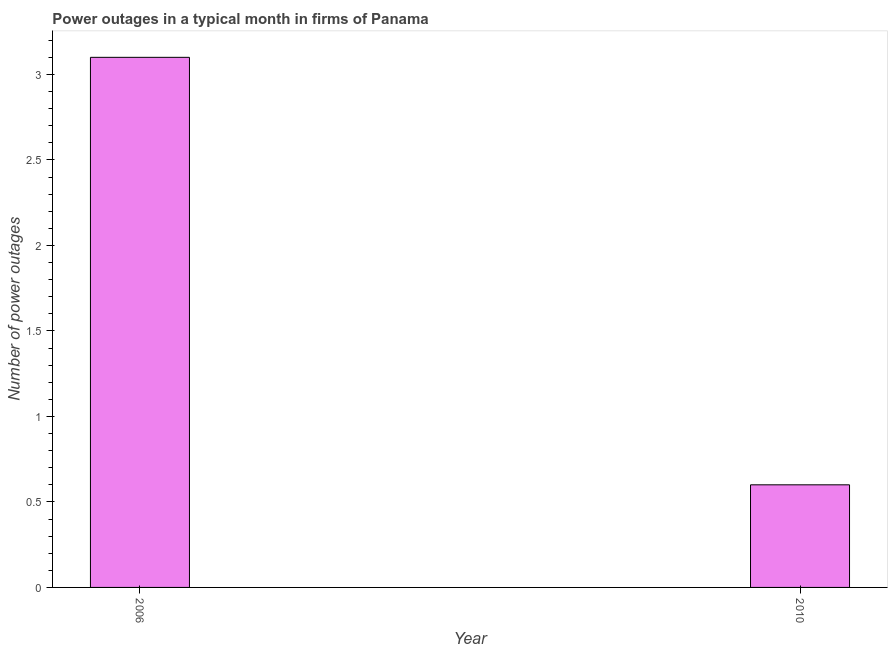What is the title of the graph?
Provide a short and direct response. Power outages in a typical month in firms of Panama. What is the label or title of the X-axis?
Provide a short and direct response. Year. What is the label or title of the Y-axis?
Give a very brief answer. Number of power outages. What is the number of power outages in 2006?
Offer a very short reply. 3.1. Across all years, what is the maximum number of power outages?
Provide a short and direct response. 3.1. Across all years, what is the minimum number of power outages?
Your response must be concise. 0.6. What is the difference between the number of power outages in 2006 and 2010?
Make the answer very short. 2.5. What is the average number of power outages per year?
Provide a short and direct response. 1.85. What is the median number of power outages?
Keep it short and to the point. 1.85. What is the ratio of the number of power outages in 2006 to that in 2010?
Give a very brief answer. 5.17. Is the number of power outages in 2006 less than that in 2010?
Give a very brief answer. No. In how many years, is the number of power outages greater than the average number of power outages taken over all years?
Your answer should be very brief. 1. How many bars are there?
Ensure brevity in your answer.  2. Are all the bars in the graph horizontal?
Make the answer very short. No. What is the Number of power outages in 2010?
Ensure brevity in your answer.  0.6. What is the ratio of the Number of power outages in 2006 to that in 2010?
Provide a short and direct response. 5.17. 